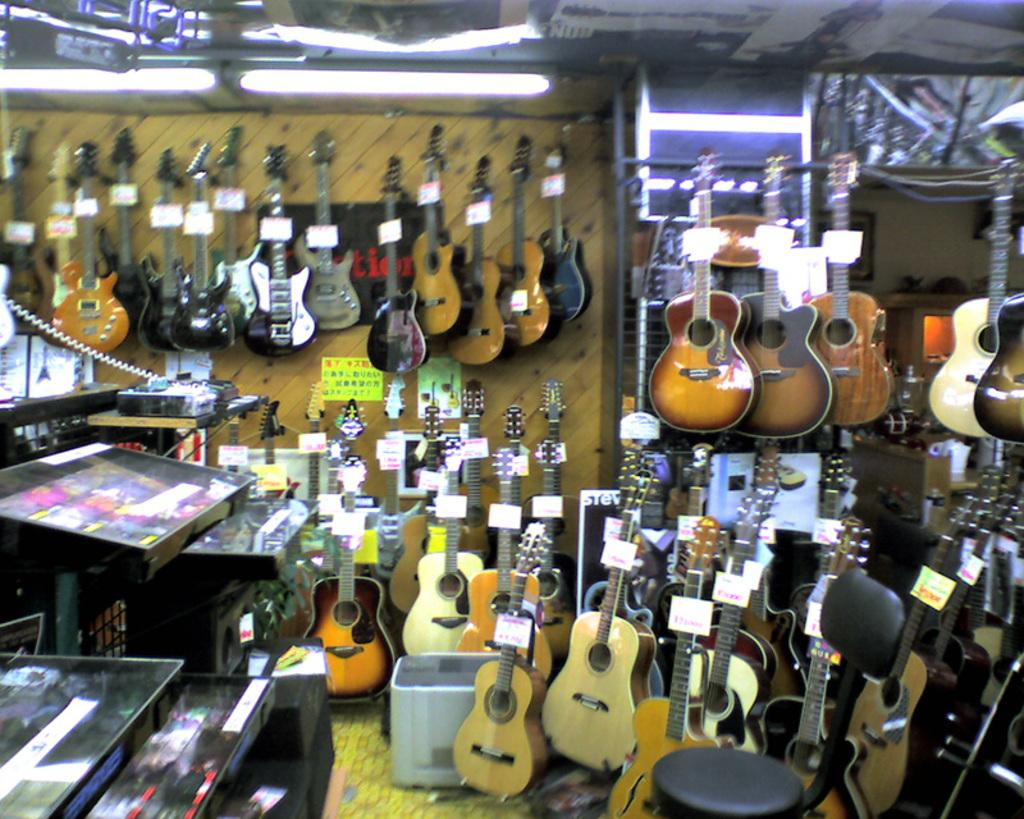What musical instruments are on the floor in the image? There are guitars on the floor in the image. What else can be seen in the image related to guitars? There are guitars on the wall in the image. What electronic devices are visible in the image? There are screens visible in the image. What type of animal can be seen playing the guitar in the image? There are no animals present in the image, and the guitars are not being played by any visible subjects. 